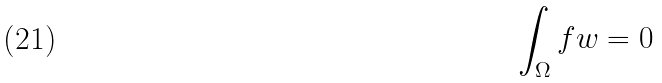Convert formula to latex. <formula><loc_0><loc_0><loc_500><loc_500>\int _ { \Omega } f w = 0</formula> 